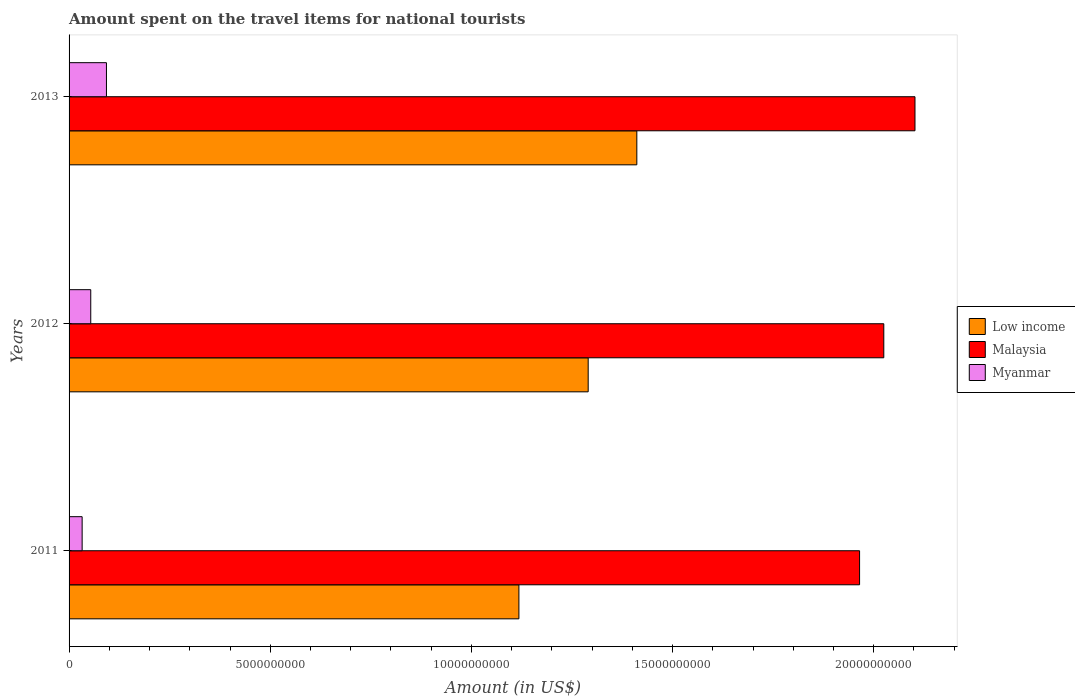Are the number of bars on each tick of the Y-axis equal?
Offer a very short reply. Yes. How many bars are there on the 1st tick from the bottom?
Provide a succinct answer. 3. What is the label of the 2nd group of bars from the top?
Offer a very short reply. 2012. In how many cases, is the number of bars for a given year not equal to the number of legend labels?
Offer a very short reply. 0. What is the amount spent on the travel items for national tourists in Low income in 2012?
Offer a terse response. 1.29e+1. Across all years, what is the maximum amount spent on the travel items for national tourists in Malaysia?
Your answer should be compact. 2.10e+1. Across all years, what is the minimum amount spent on the travel items for national tourists in Myanmar?
Give a very brief answer. 3.25e+08. What is the total amount spent on the travel items for national tourists in Malaysia in the graph?
Provide a short and direct response. 6.09e+1. What is the difference between the amount spent on the travel items for national tourists in Malaysia in 2011 and that in 2013?
Give a very brief answer. -1.38e+09. What is the difference between the amount spent on the travel items for national tourists in Malaysia in 2011 and the amount spent on the travel items for national tourists in Myanmar in 2013?
Provide a succinct answer. 1.87e+1. What is the average amount spent on the travel items for national tourists in Low income per year?
Your answer should be very brief. 1.27e+1. In the year 2013, what is the difference between the amount spent on the travel items for national tourists in Malaysia and amount spent on the travel items for national tourists in Low income?
Your answer should be compact. 6.91e+09. What is the ratio of the amount spent on the travel items for national tourists in Malaysia in 2012 to that in 2013?
Make the answer very short. 0.96. What is the difference between the highest and the second highest amount spent on the travel items for national tourists in Myanmar?
Your response must be concise. 3.90e+08. What is the difference between the highest and the lowest amount spent on the travel items for national tourists in Myanmar?
Make the answer very short. 6.04e+08. In how many years, is the amount spent on the travel items for national tourists in Myanmar greater than the average amount spent on the travel items for national tourists in Myanmar taken over all years?
Provide a short and direct response. 1. Is the sum of the amount spent on the travel items for national tourists in Low income in 2011 and 2012 greater than the maximum amount spent on the travel items for national tourists in Malaysia across all years?
Ensure brevity in your answer.  Yes. What does the 2nd bar from the top in 2013 represents?
Provide a short and direct response. Malaysia. What does the 3rd bar from the bottom in 2012 represents?
Ensure brevity in your answer.  Myanmar. Are all the bars in the graph horizontal?
Offer a very short reply. Yes. Does the graph contain any zero values?
Your response must be concise. No. How many legend labels are there?
Give a very brief answer. 3. What is the title of the graph?
Offer a terse response. Amount spent on the travel items for national tourists. What is the Amount (in US$) of Low income in 2011?
Provide a succinct answer. 1.12e+1. What is the Amount (in US$) of Malaysia in 2011?
Your answer should be compact. 1.96e+1. What is the Amount (in US$) in Myanmar in 2011?
Give a very brief answer. 3.25e+08. What is the Amount (in US$) of Low income in 2012?
Your answer should be compact. 1.29e+1. What is the Amount (in US$) of Malaysia in 2012?
Give a very brief answer. 2.03e+1. What is the Amount (in US$) in Myanmar in 2012?
Offer a very short reply. 5.39e+08. What is the Amount (in US$) in Low income in 2013?
Give a very brief answer. 1.41e+1. What is the Amount (in US$) in Malaysia in 2013?
Provide a succinct answer. 2.10e+1. What is the Amount (in US$) of Myanmar in 2013?
Make the answer very short. 9.29e+08. Across all years, what is the maximum Amount (in US$) of Low income?
Make the answer very short. 1.41e+1. Across all years, what is the maximum Amount (in US$) in Malaysia?
Provide a short and direct response. 2.10e+1. Across all years, what is the maximum Amount (in US$) of Myanmar?
Offer a terse response. 9.29e+08. Across all years, what is the minimum Amount (in US$) of Low income?
Your response must be concise. 1.12e+1. Across all years, what is the minimum Amount (in US$) of Malaysia?
Ensure brevity in your answer.  1.96e+1. Across all years, what is the minimum Amount (in US$) in Myanmar?
Give a very brief answer. 3.25e+08. What is the total Amount (in US$) of Low income in the graph?
Your answer should be very brief. 3.82e+1. What is the total Amount (in US$) of Malaysia in the graph?
Make the answer very short. 6.09e+1. What is the total Amount (in US$) in Myanmar in the graph?
Make the answer very short. 1.79e+09. What is the difference between the Amount (in US$) of Low income in 2011 and that in 2012?
Provide a short and direct response. -1.72e+09. What is the difference between the Amount (in US$) in Malaysia in 2011 and that in 2012?
Make the answer very short. -6.02e+08. What is the difference between the Amount (in US$) of Myanmar in 2011 and that in 2012?
Offer a very short reply. -2.14e+08. What is the difference between the Amount (in US$) of Low income in 2011 and that in 2013?
Give a very brief answer. -2.93e+09. What is the difference between the Amount (in US$) in Malaysia in 2011 and that in 2013?
Offer a terse response. -1.38e+09. What is the difference between the Amount (in US$) of Myanmar in 2011 and that in 2013?
Your response must be concise. -6.04e+08. What is the difference between the Amount (in US$) in Low income in 2012 and that in 2013?
Make the answer very short. -1.21e+09. What is the difference between the Amount (in US$) of Malaysia in 2012 and that in 2013?
Ensure brevity in your answer.  -7.75e+08. What is the difference between the Amount (in US$) of Myanmar in 2012 and that in 2013?
Ensure brevity in your answer.  -3.90e+08. What is the difference between the Amount (in US$) in Low income in 2011 and the Amount (in US$) in Malaysia in 2012?
Keep it short and to the point. -9.07e+09. What is the difference between the Amount (in US$) in Low income in 2011 and the Amount (in US$) in Myanmar in 2012?
Give a very brief answer. 1.06e+1. What is the difference between the Amount (in US$) in Malaysia in 2011 and the Amount (in US$) in Myanmar in 2012?
Your answer should be compact. 1.91e+1. What is the difference between the Amount (in US$) of Low income in 2011 and the Amount (in US$) of Malaysia in 2013?
Provide a succinct answer. -9.84e+09. What is the difference between the Amount (in US$) in Low income in 2011 and the Amount (in US$) in Myanmar in 2013?
Ensure brevity in your answer.  1.03e+1. What is the difference between the Amount (in US$) in Malaysia in 2011 and the Amount (in US$) in Myanmar in 2013?
Your answer should be very brief. 1.87e+1. What is the difference between the Amount (in US$) in Low income in 2012 and the Amount (in US$) in Malaysia in 2013?
Provide a short and direct response. -8.12e+09. What is the difference between the Amount (in US$) of Low income in 2012 and the Amount (in US$) of Myanmar in 2013?
Provide a short and direct response. 1.20e+1. What is the difference between the Amount (in US$) of Malaysia in 2012 and the Amount (in US$) of Myanmar in 2013?
Ensure brevity in your answer.  1.93e+1. What is the average Amount (in US$) of Low income per year?
Offer a terse response. 1.27e+1. What is the average Amount (in US$) in Malaysia per year?
Your answer should be compact. 2.03e+1. What is the average Amount (in US$) in Myanmar per year?
Provide a short and direct response. 5.98e+08. In the year 2011, what is the difference between the Amount (in US$) of Low income and Amount (in US$) of Malaysia?
Your answer should be very brief. -8.47e+09. In the year 2011, what is the difference between the Amount (in US$) of Low income and Amount (in US$) of Myanmar?
Keep it short and to the point. 1.09e+1. In the year 2011, what is the difference between the Amount (in US$) of Malaysia and Amount (in US$) of Myanmar?
Keep it short and to the point. 1.93e+1. In the year 2012, what is the difference between the Amount (in US$) of Low income and Amount (in US$) of Malaysia?
Ensure brevity in your answer.  -7.35e+09. In the year 2012, what is the difference between the Amount (in US$) in Low income and Amount (in US$) in Myanmar?
Your response must be concise. 1.24e+1. In the year 2012, what is the difference between the Amount (in US$) in Malaysia and Amount (in US$) in Myanmar?
Provide a short and direct response. 1.97e+1. In the year 2013, what is the difference between the Amount (in US$) in Low income and Amount (in US$) in Malaysia?
Provide a succinct answer. -6.91e+09. In the year 2013, what is the difference between the Amount (in US$) of Low income and Amount (in US$) of Myanmar?
Your answer should be compact. 1.32e+1. In the year 2013, what is the difference between the Amount (in US$) in Malaysia and Amount (in US$) in Myanmar?
Ensure brevity in your answer.  2.01e+1. What is the ratio of the Amount (in US$) in Low income in 2011 to that in 2012?
Your response must be concise. 0.87. What is the ratio of the Amount (in US$) in Malaysia in 2011 to that in 2012?
Your response must be concise. 0.97. What is the ratio of the Amount (in US$) in Myanmar in 2011 to that in 2012?
Your answer should be compact. 0.6. What is the ratio of the Amount (in US$) of Low income in 2011 to that in 2013?
Your answer should be very brief. 0.79. What is the ratio of the Amount (in US$) in Malaysia in 2011 to that in 2013?
Ensure brevity in your answer.  0.93. What is the ratio of the Amount (in US$) in Myanmar in 2011 to that in 2013?
Make the answer very short. 0.35. What is the ratio of the Amount (in US$) in Low income in 2012 to that in 2013?
Provide a short and direct response. 0.91. What is the ratio of the Amount (in US$) of Malaysia in 2012 to that in 2013?
Ensure brevity in your answer.  0.96. What is the ratio of the Amount (in US$) in Myanmar in 2012 to that in 2013?
Make the answer very short. 0.58. What is the difference between the highest and the second highest Amount (in US$) of Low income?
Make the answer very short. 1.21e+09. What is the difference between the highest and the second highest Amount (in US$) of Malaysia?
Your answer should be compact. 7.75e+08. What is the difference between the highest and the second highest Amount (in US$) in Myanmar?
Provide a short and direct response. 3.90e+08. What is the difference between the highest and the lowest Amount (in US$) of Low income?
Offer a very short reply. 2.93e+09. What is the difference between the highest and the lowest Amount (in US$) of Malaysia?
Offer a very short reply. 1.38e+09. What is the difference between the highest and the lowest Amount (in US$) of Myanmar?
Provide a succinct answer. 6.04e+08. 